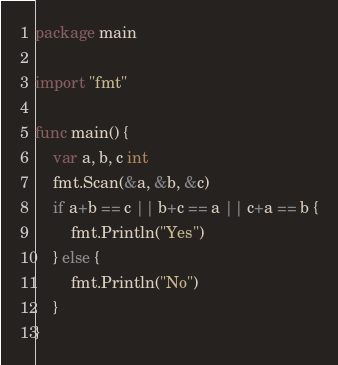<code> <loc_0><loc_0><loc_500><loc_500><_Go_>package main

import "fmt"

func main() {
	var a, b, c int
	fmt.Scan(&a, &b, &c)
	if a+b == c || b+c == a || c+a == b {
		fmt.Println("Yes")
	} else {
		fmt.Println("No")
	}
}
</code> 